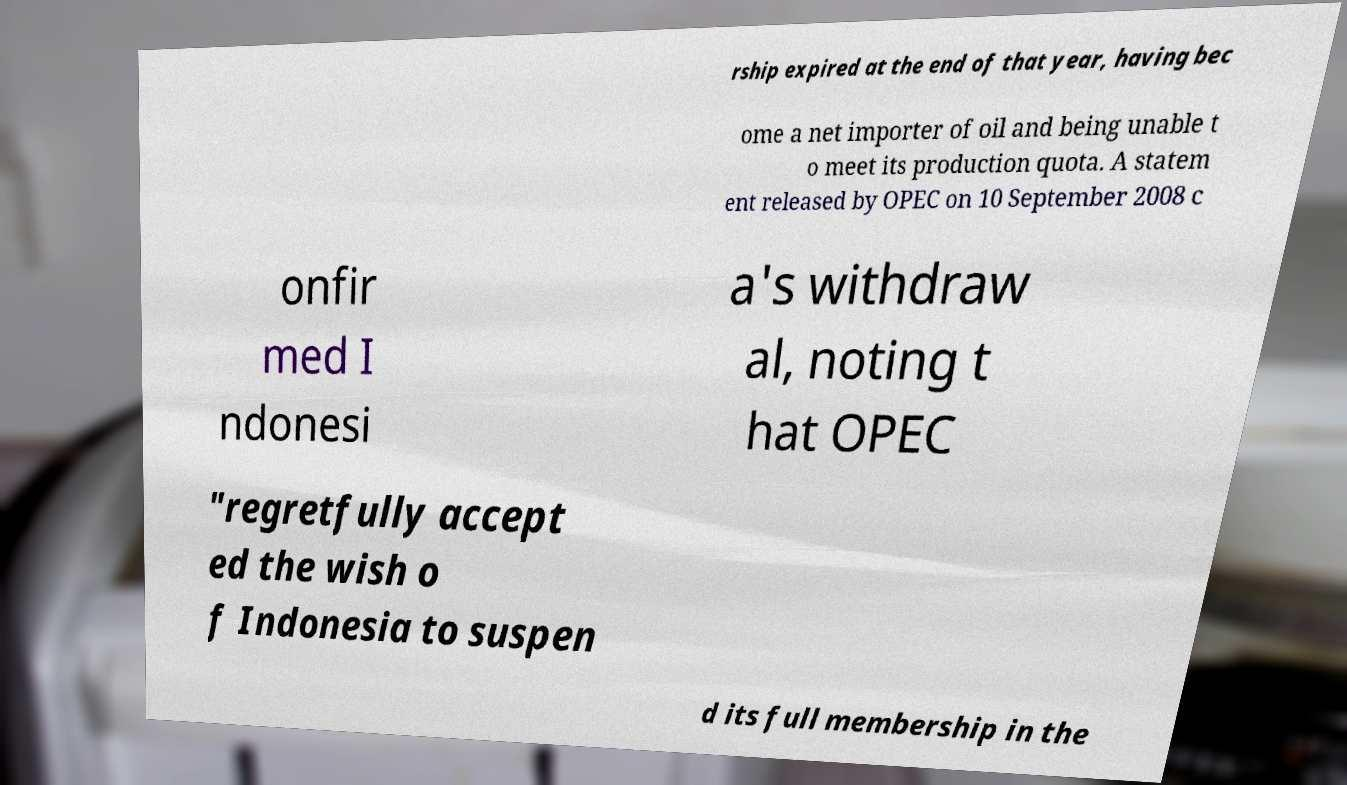For documentation purposes, I need the text within this image transcribed. Could you provide that? rship expired at the end of that year, having bec ome a net importer of oil and being unable t o meet its production quota. A statem ent released by OPEC on 10 September 2008 c onfir med I ndonesi a's withdraw al, noting t hat OPEC "regretfully accept ed the wish o f Indonesia to suspen d its full membership in the 